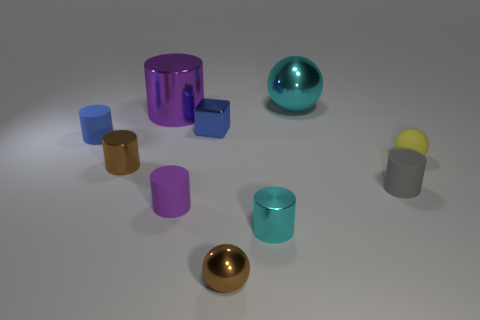Subtract all brown metal cylinders. How many cylinders are left? 5 Subtract all gray cylinders. How many cylinders are left? 5 Subtract all green cylinders. Subtract all red balls. How many cylinders are left? 6 Subtract all cubes. How many objects are left? 9 Add 3 small gray rubber cylinders. How many small gray rubber cylinders exist? 4 Subtract 1 yellow balls. How many objects are left? 9 Subtract all gray rubber cylinders. Subtract all small gray matte cylinders. How many objects are left? 8 Add 1 brown cylinders. How many brown cylinders are left? 2 